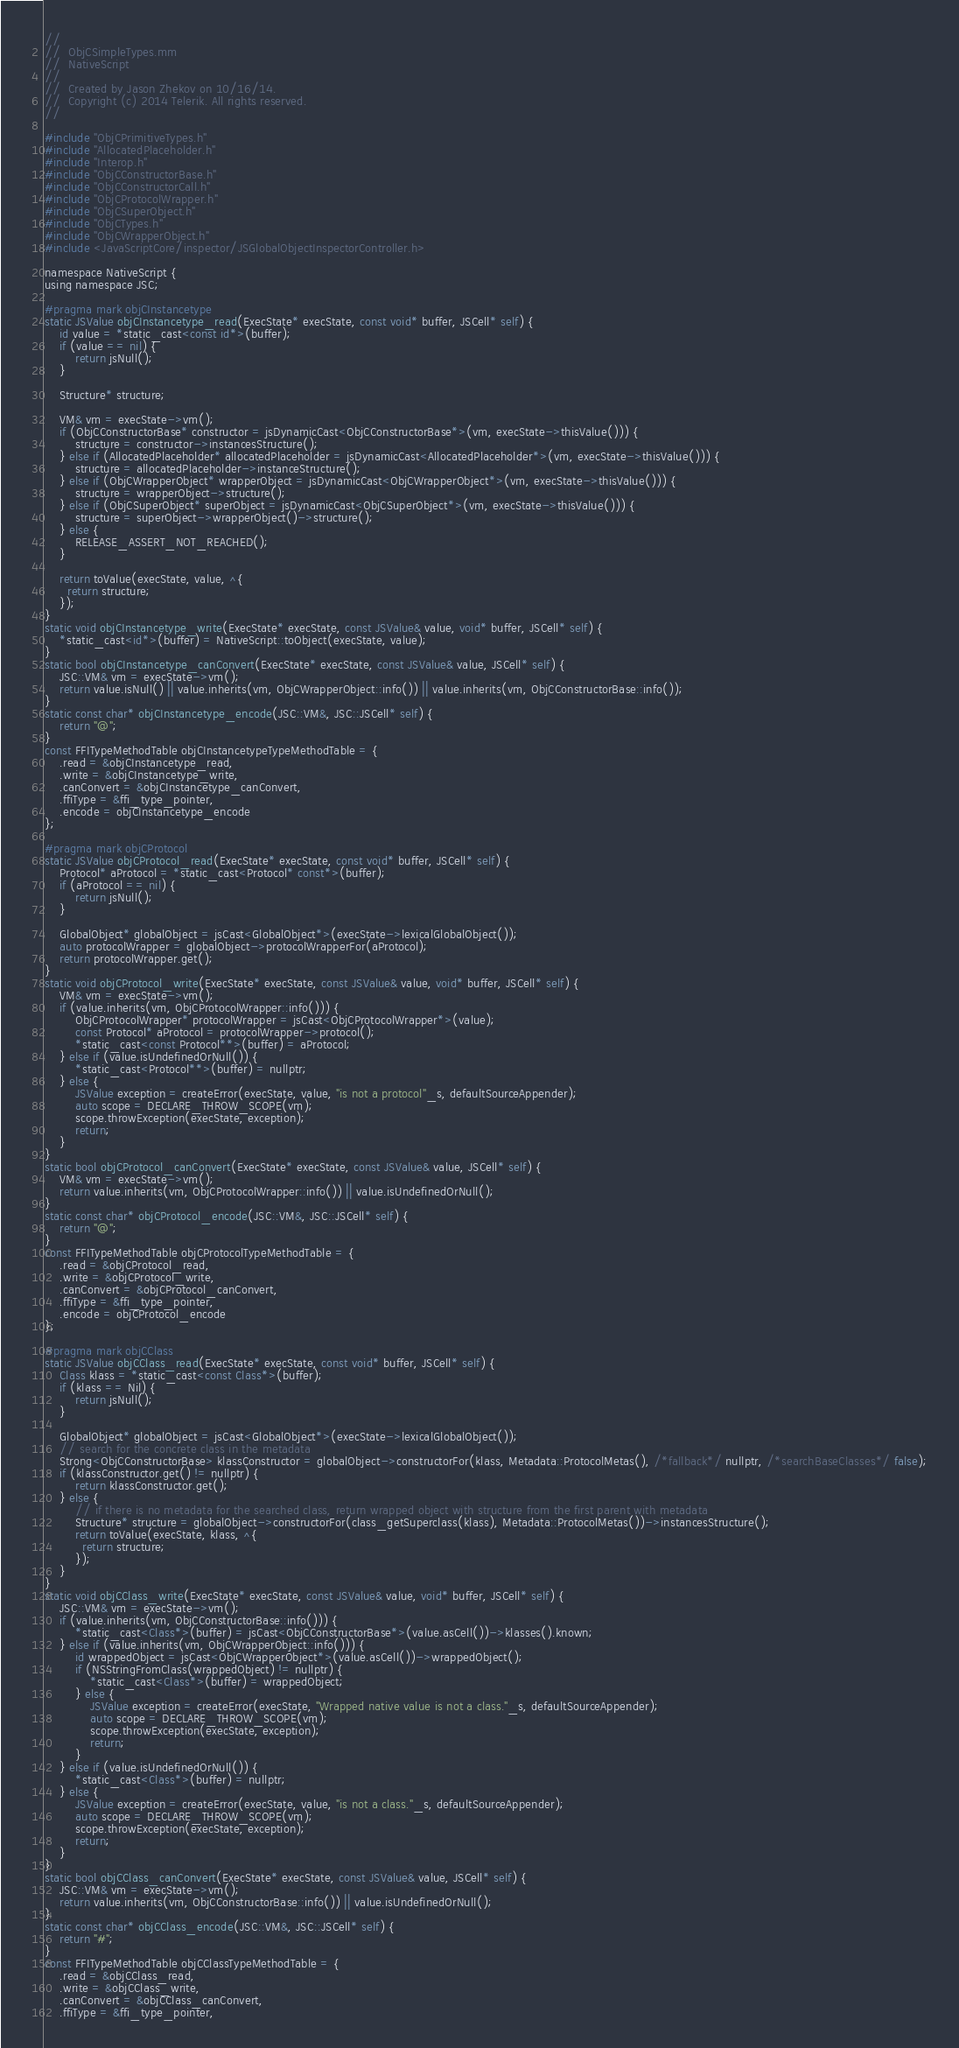<code> <loc_0><loc_0><loc_500><loc_500><_ObjectiveC_>//
//  ObjCSimpleTypes.mm
//  NativeScript
//
//  Created by Jason Zhekov on 10/16/14.
//  Copyright (c) 2014 Telerik. All rights reserved.
//

#include "ObjCPrimitiveTypes.h"
#include "AllocatedPlaceholder.h"
#include "Interop.h"
#include "ObjCConstructorBase.h"
#include "ObjCConstructorCall.h"
#include "ObjCProtocolWrapper.h"
#include "ObjCSuperObject.h"
#include "ObjCTypes.h"
#include "ObjCWrapperObject.h"
#include <JavaScriptCore/inspector/JSGlobalObjectInspectorController.h>

namespace NativeScript {
using namespace JSC;

#pragma mark objCInstancetype
static JSValue objCInstancetype_read(ExecState* execState, const void* buffer, JSCell* self) {
    id value = *static_cast<const id*>(buffer);
    if (value == nil) {
        return jsNull();
    }

    Structure* structure;

    VM& vm = execState->vm();
    if (ObjCConstructorBase* constructor = jsDynamicCast<ObjCConstructorBase*>(vm, execState->thisValue())) {
        structure = constructor->instancesStructure();
    } else if (AllocatedPlaceholder* allocatedPlaceholder = jsDynamicCast<AllocatedPlaceholder*>(vm, execState->thisValue())) {
        structure = allocatedPlaceholder->instanceStructure();
    } else if (ObjCWrapperObject* wrapperObject = jsDynamicCast<ObjCWrapperObject*>(vm, execState->thisValue())) {
        structure = wrapperObject->structure();
    } else if (ObjCSuperObject* superObject = jsDynamicCast<ObjCSuperObject*>(vm, execState->thisValue())) {
        structure = superObject->wrapperObject()->structure();
    } else {
        RELEASE_ASSERT_NOT_REACHED();
    }

    return toValue(execState, value, ^{
      return structure;
    });
}
static void objCInstancetype_write(ExecState* execState, const JSValue& value, void* buffer, JSCell* self) {
    *static_cast<id*>(buffer) = NativeScript::toObject(execState, value);
}
static bool objCInstancetype_canConvert(ExecState* execState, const JSValue& value, JSCell* self) {
    JSC::VM& vm = execState->vm();
    return value.isNull() || value.inherits(vm, ObjCWrapperObject::info()) || value.inherits(vm, ObjCConstructorBase::info());
}
static const char* objCInstancetype_encode(JSC::VM&, JSC::JSCell* self) {
    return "@";
}
const FFITypeMethodTable objCInstancetypeTypeMethodTable = {
    .read = &objCInstancetype_read,
    .write = &objCInstancetype_write,
    .canConvert = &objCInstancetype_canConvert,
    .ffiType = &ffi_type_pointer,
    .encode = objCInstancetype_encode
};

#pragma mark objCProtocol
static JSValue objCProtocol_read(ExecState* execState, const void* buffer, JSCell* self) {
    Protocol* aProtocol = *static_cast<Protocol* const*>(buffer);
    if (aProtocol == nil) {
        return jsNull();
    }

    GlobalObject* globalObject = jsCast<GlobalObject*>(execState->lexicalGlobalObject());
    auto protocolWrapper = globalObject->protocolWrapperFor(aProtocol);
    return protocolWrapper.get();
}
static void objCProtocol_write(ExecState* execState, const JSValue& value, void* buffer, JSCell* self) {
    VM& vm = execState->vm();
    if (value.inherits(vm, ObjCProtocolWrapper::info())) {
        ObjCProtocolWrapper* protocolWrapper = jsCast<ObjCProtocolWrapper*>(value);
        const Protocol* aProtocol = protocolWrapper->protocol();
        *static_cast<const Protocol**>(buffer) = aProtocol;
    } else if (value.isUndefinedOrNull()) {
        *static_cast<Protocol**>(buffer) = nullptr;
    } else {
        JSValue exception = createError(execState, value, "is not a protocol"_s, defaultSourceAppender);
        auto scope = DECLARE_THROW_SCOPE(vm);
        scope.throwException(execState, exception);
        return;
    }
}
static bool objCProtocol_canConvert(ExecState* execState, const JSValue& value, JSCell* self) {
    VM& vm = execState->vm();
    return value.inherits(vm, ObjCProtocolWrapper::info()) || value.isUndefinedOrNull();
}
static const char* objCProtocol_encode(JSC::VM&, JSC::JSCell* self) {
    return "@";
}
const FFITypeMethodTable objCProtocolTypeMethodTable = {
    .read = &objCProtocol_read,
    .write = &objCProtocol_write,
    .canConvert = &objCProtocol_canConvert,
    .ffiType = &ffi_type_pointer,
    .encode = objCProtocol_encode
};

#pragma mark objCClass
static JSValue objCClass_read(ExecState* execState, const void* buffer, JSCell* self) {
    Class klass = *static_cast<const Class*>(buffer);
    if (klass == Nil) {
        return jsNull();
    }

    GlobalObject* globalObject = jsCast<GlobalObject*>(execState->lexicalGlobalObject());
    // search for the concrete class in the metadata
    Strong<ObjCConstructorBase> klassConstructor = globalObject->constructorFor(klass, Metadata::ProtocolMetas(), /*fallback*/ nullptr, /*searchBaseClasses*/ false);
    if (klassConstructor.get() != nullptr) {
        return klassConstructor.get();
    } else {
        // if there is no metadata for the searched class, return wrapped object with structure from the first parent with metadata
        Structure* structure = globalObject->constructorFor(class_getSuperclass(klass), Metadata::ProtocolMetas())->instancesStructure();
        return toValue(execState, klass, ^{
          return structure;
        });
    }
}
static void objCClass_write(ExecState* execState, const JSValue& value, void* buffer, JSCell* self) {
    JSC::VM& vm = execState->vm();
    if (value.inherits(vm, ObjCConstructorBase::info())) {
        *static_cast<Class*>(buffer) = jsCast<ObjCConstructorBase*>(value.asCell())->klasses().known;
    } else if (value.inherits(vm, ObjCWrapperObject::info())) {
        id wrappedObject = jsCast<ObjCWrapperObject*>(value.asCell())->wrappedObject();
        if (NSStringFromClass(wrappedObject) != nullptr) {
            *static_cast<Class*>(buffer) = wrappedObject;
        } else {
            JSValue exception = createError(execState, "Wrapped native value is not a class."_s, defaultSourceAppender);
            auto scope = DECLARE_THROW_SCOPE(vm);
            scope.throwException(execState, exception);
            return;
        }
    } else if (value.isUndefinedOrNull()) {
        *static_cast<Class*>(buffer) = nullptr;
    } else {
        JSValue exception = createError(execState, value, "is not a class."_s, defaultSourceAppender);
        auto scope = DECLARE_THROW_SCOPE(vm);
        scope.throwException(execState, exception);
        return;
    }
}
static bool objCClass_canConvert(ExecState* execState, const JSValue& value, JSCell* self) {
    JSC::VM& vm = execState->vm();
    return value.inherits(vm, ObjCConstructorBase::info()) || value.isUndefinedOrNull();
}
static const char* objCClass_encode(JSC::VM&, JSC::JSCell* self) {
    return "#";
}
const FFITypeMethodTable objCClassTypeMethodTable = {
    .read = &objCClass_read,
    .write = &objCClass_write,
    .canConvert = &objCClass_canConvert,
    .ffiType = &ffi_type_pointer,</code> 